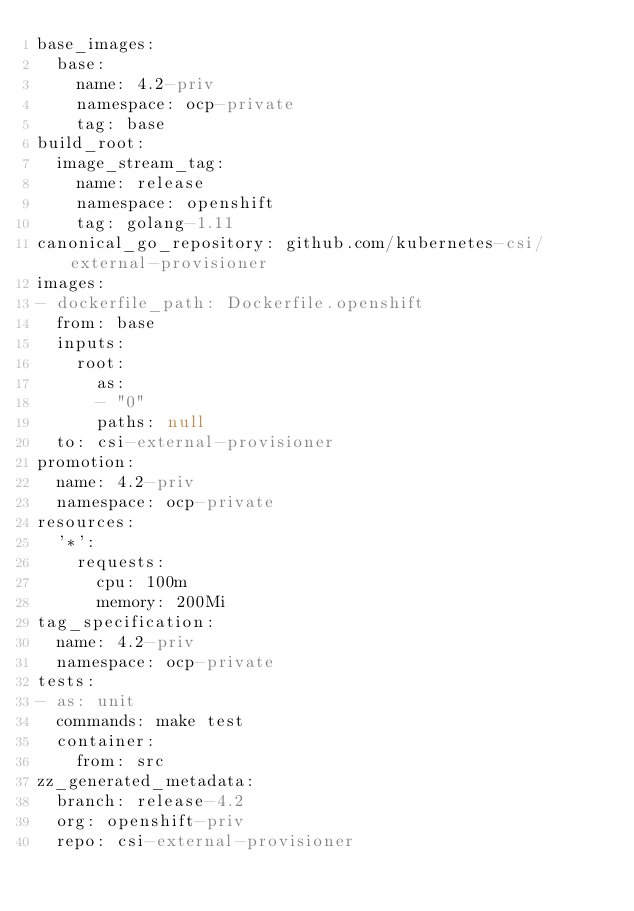Convert code to text. <code><loc_0><loc_0><loc_500><loc_500><_YAML_>base_images:
  base:
    name: 4.2-priv
    namespace: ocp-private
    tag: base
build_root:
  image_stream_tag:
    name: release
    namespace: openshift
    tag: golang-1.11
canonical_go_repository: github.com/kubernetes-csi/external-provisioner
images:
- dockerfile_path: Dockerfile.openshift
  from: base
  inputs:
    root:
      as:
      - "0"
      paths: null
  to: csi-external-provisioner
promotion:
  name: 4.2-priv
  namespace: ocp-private
resources:
  '*':
    requests:
      cpu: 100m
      memory: 200Mi
tag_specification:
  name: 4.2-priv
  namespace: ocp-private
tests:
- as: unit
  commands: make test
  container:
    from: src
zz_generated_metadata:
  branch: release-4.2
  org: openshift-priv
  repo: csi-external-provisioner
</code> 